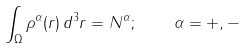<formula> <loc_0><loc_0><loc_500><loc_500>\int _ { \Omega } \rho ^ { \alpha } ( { r } ) \, d ^ { 3 } { r } = N ^ { \alpha } ; \quad \alpha = + , -</formula> 